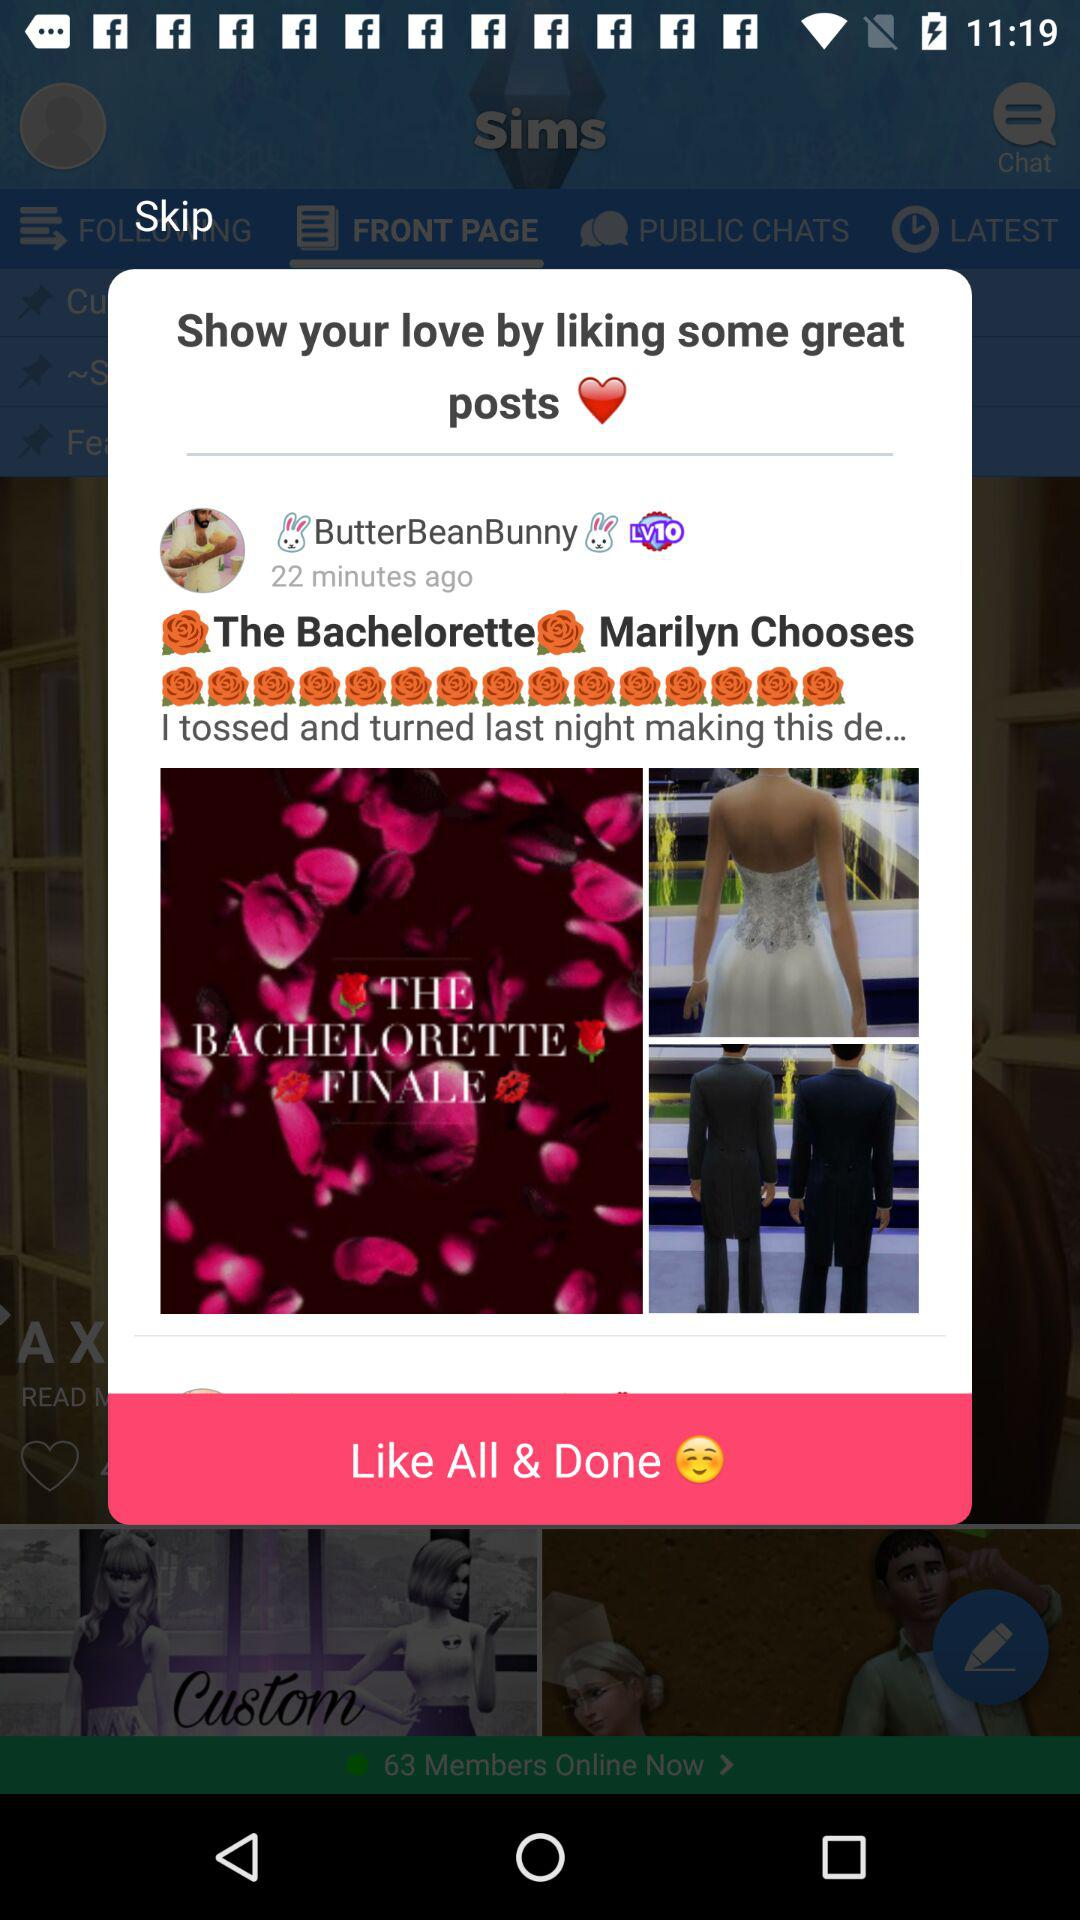When was the post posted? The post was posted 22 minutes ago. 